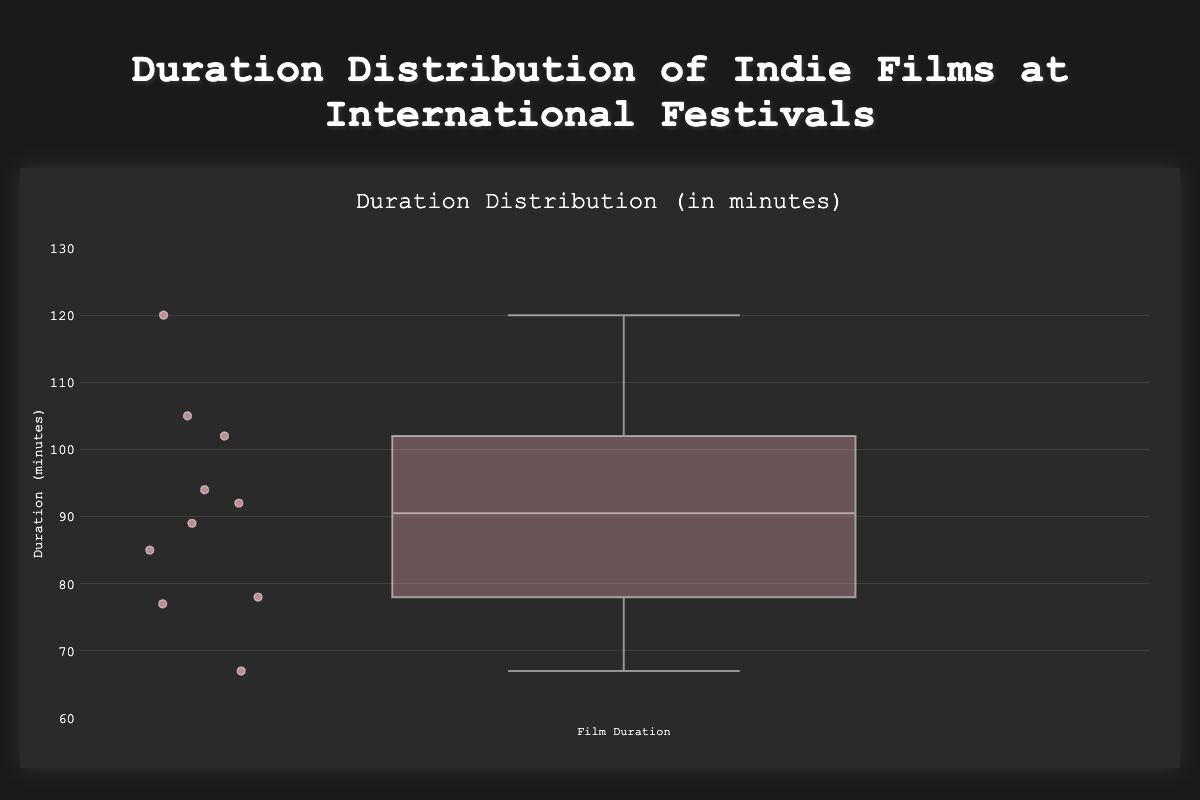what is the title of the chart? The title of the chart is displayed at the very top of the figure in a larger, bold font. By reading the text presented as the title, we can identify it.
Answer: Duration Distribution of Indie Films at International Festivals What is the range of the y-axis? The range of the y-axis is indicated by the lowest and highest values shown on the axis. From the provided layout details, the range is specified from 60 to 130 minutes.
Answer: 60 to 130 Which film has the longest duration? The point representing the longest duration on the box plot will be positioned highest on the y-axis. By hovering over the point or referring to the hover information, "Eternal Midnight" has the longest duration at 120 minutes.
Answer: Eternal Midnight What's the median duration of indie films? The median duration is indicated by the line inside the box. It separates the lower half of the data from the upper half. By finding the y-coordinate of this line, we can determine the median value.
Answer: Approximately 89 minutes Which film festivals featured films from the USA? Using the hover information on each data point, we identify the country associated with each festival. Films from the USA in the plot are "The Silent Whisper" and "Eternal Midnight," screened at the Sundance Film Festival and SXSW, respectively.
Answer: Sundance Film Festival, SXSW How many films have durations below 80 minutes? Points below 80 minutes on the y-axis count towards the total. Inspecting these points and their hover information, we identify "Echoes of the Past," "Whispers in the Wind," and "The Journey Within," totaling three films.
Answer: 3 What is the interquartile range (IQR) of the durations? The IQR is calculated by subtracting the duration at the lower quartile (Q1) from the duration at the upper quartile (Q3). Observation of the box boundaries gives Q1 around 77 minutes and Q3 around 102 minutes; thus, IQR is 102 - 77.
Answer: 25 minutes Which film has a duration closest to the median? By identifying the median value on the box plot (approximately 89 minutes) and inspecting the hover information, "A Song for Tomorrow" closely matches this median duration.
Answer: A Song for Tomorrow What is the total number of films screened at the festivals? The total number of data points represented in the box plot correlates with the number of films. Counting each point or referring to the dataset, there are ten films in total.
Answer: 10 Is there an outlier in the film durations? In a box plot, outliers are typically marked as individual points separated from the main box and whiskers. By examining the plot, there do not appear to be any distinct outliers marked.
Answer: No 